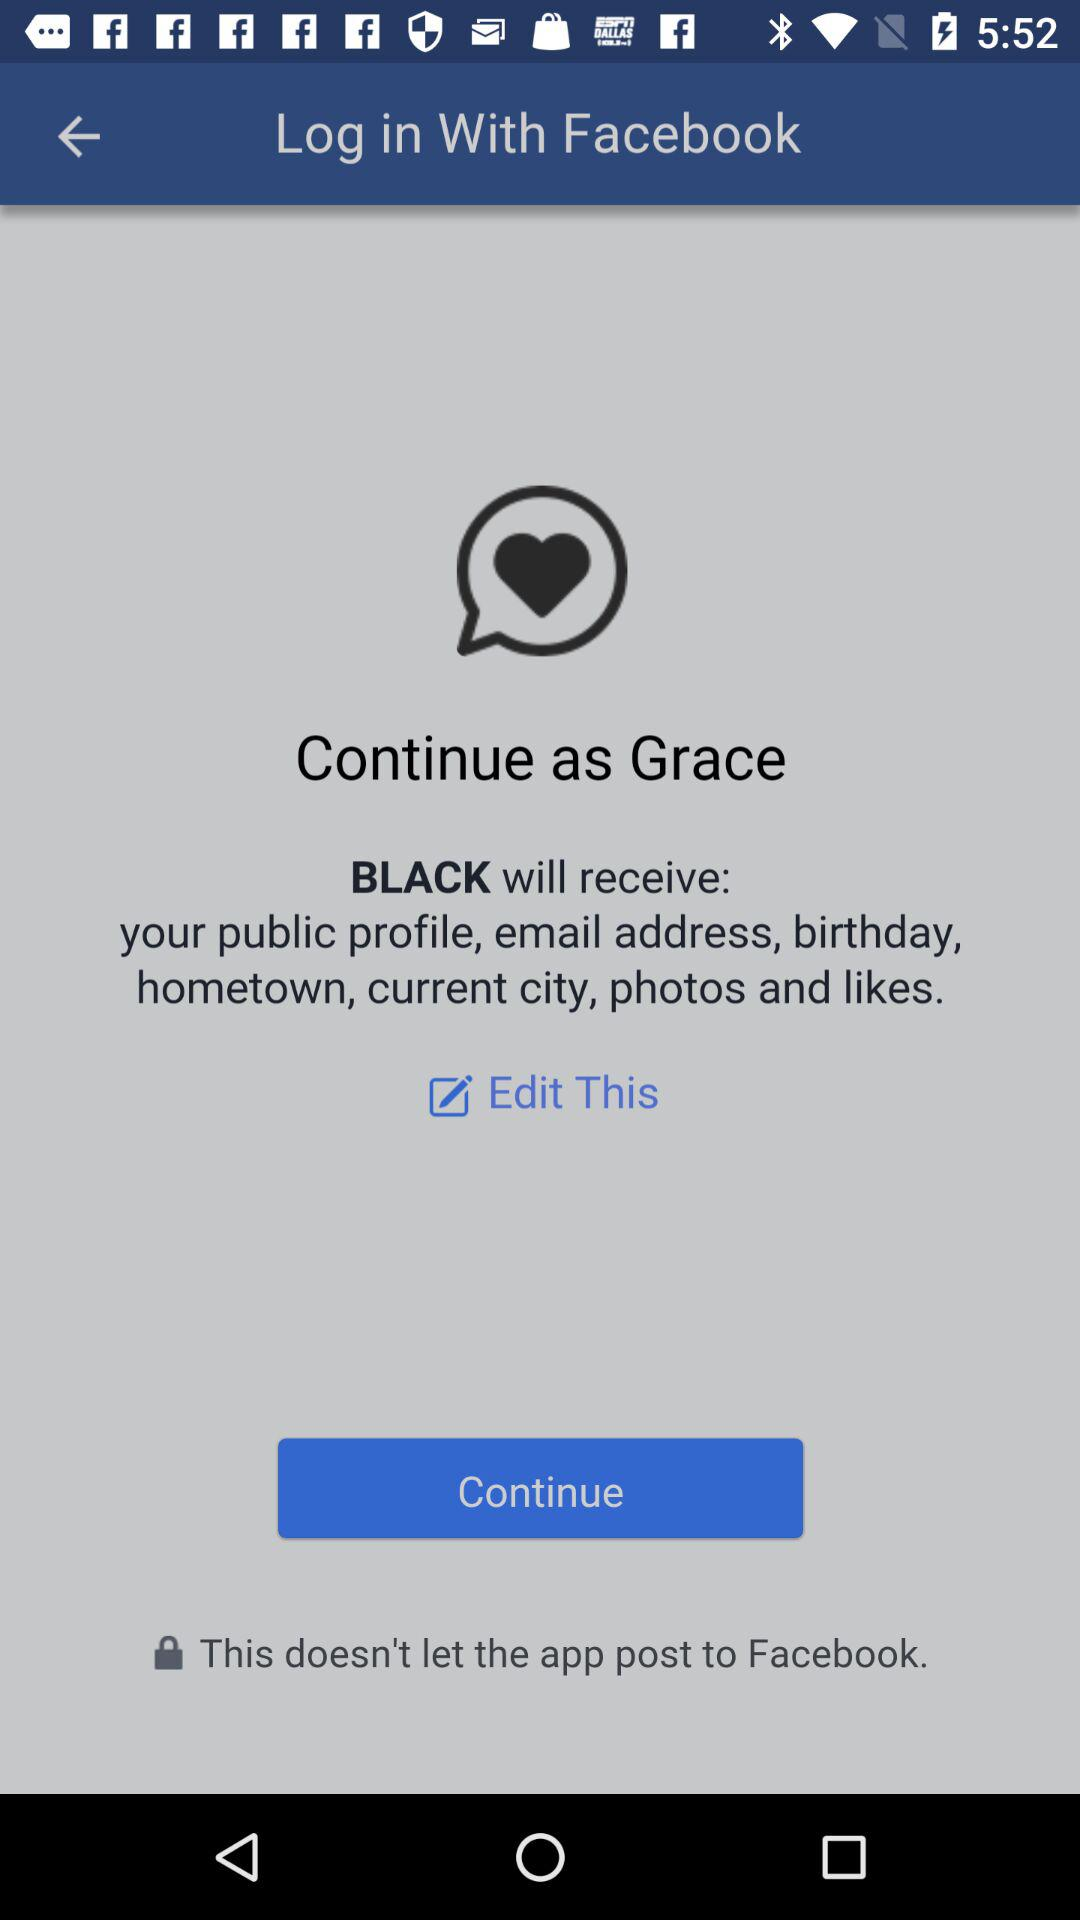Through which application can we log in? You can log in through "Facebook". 